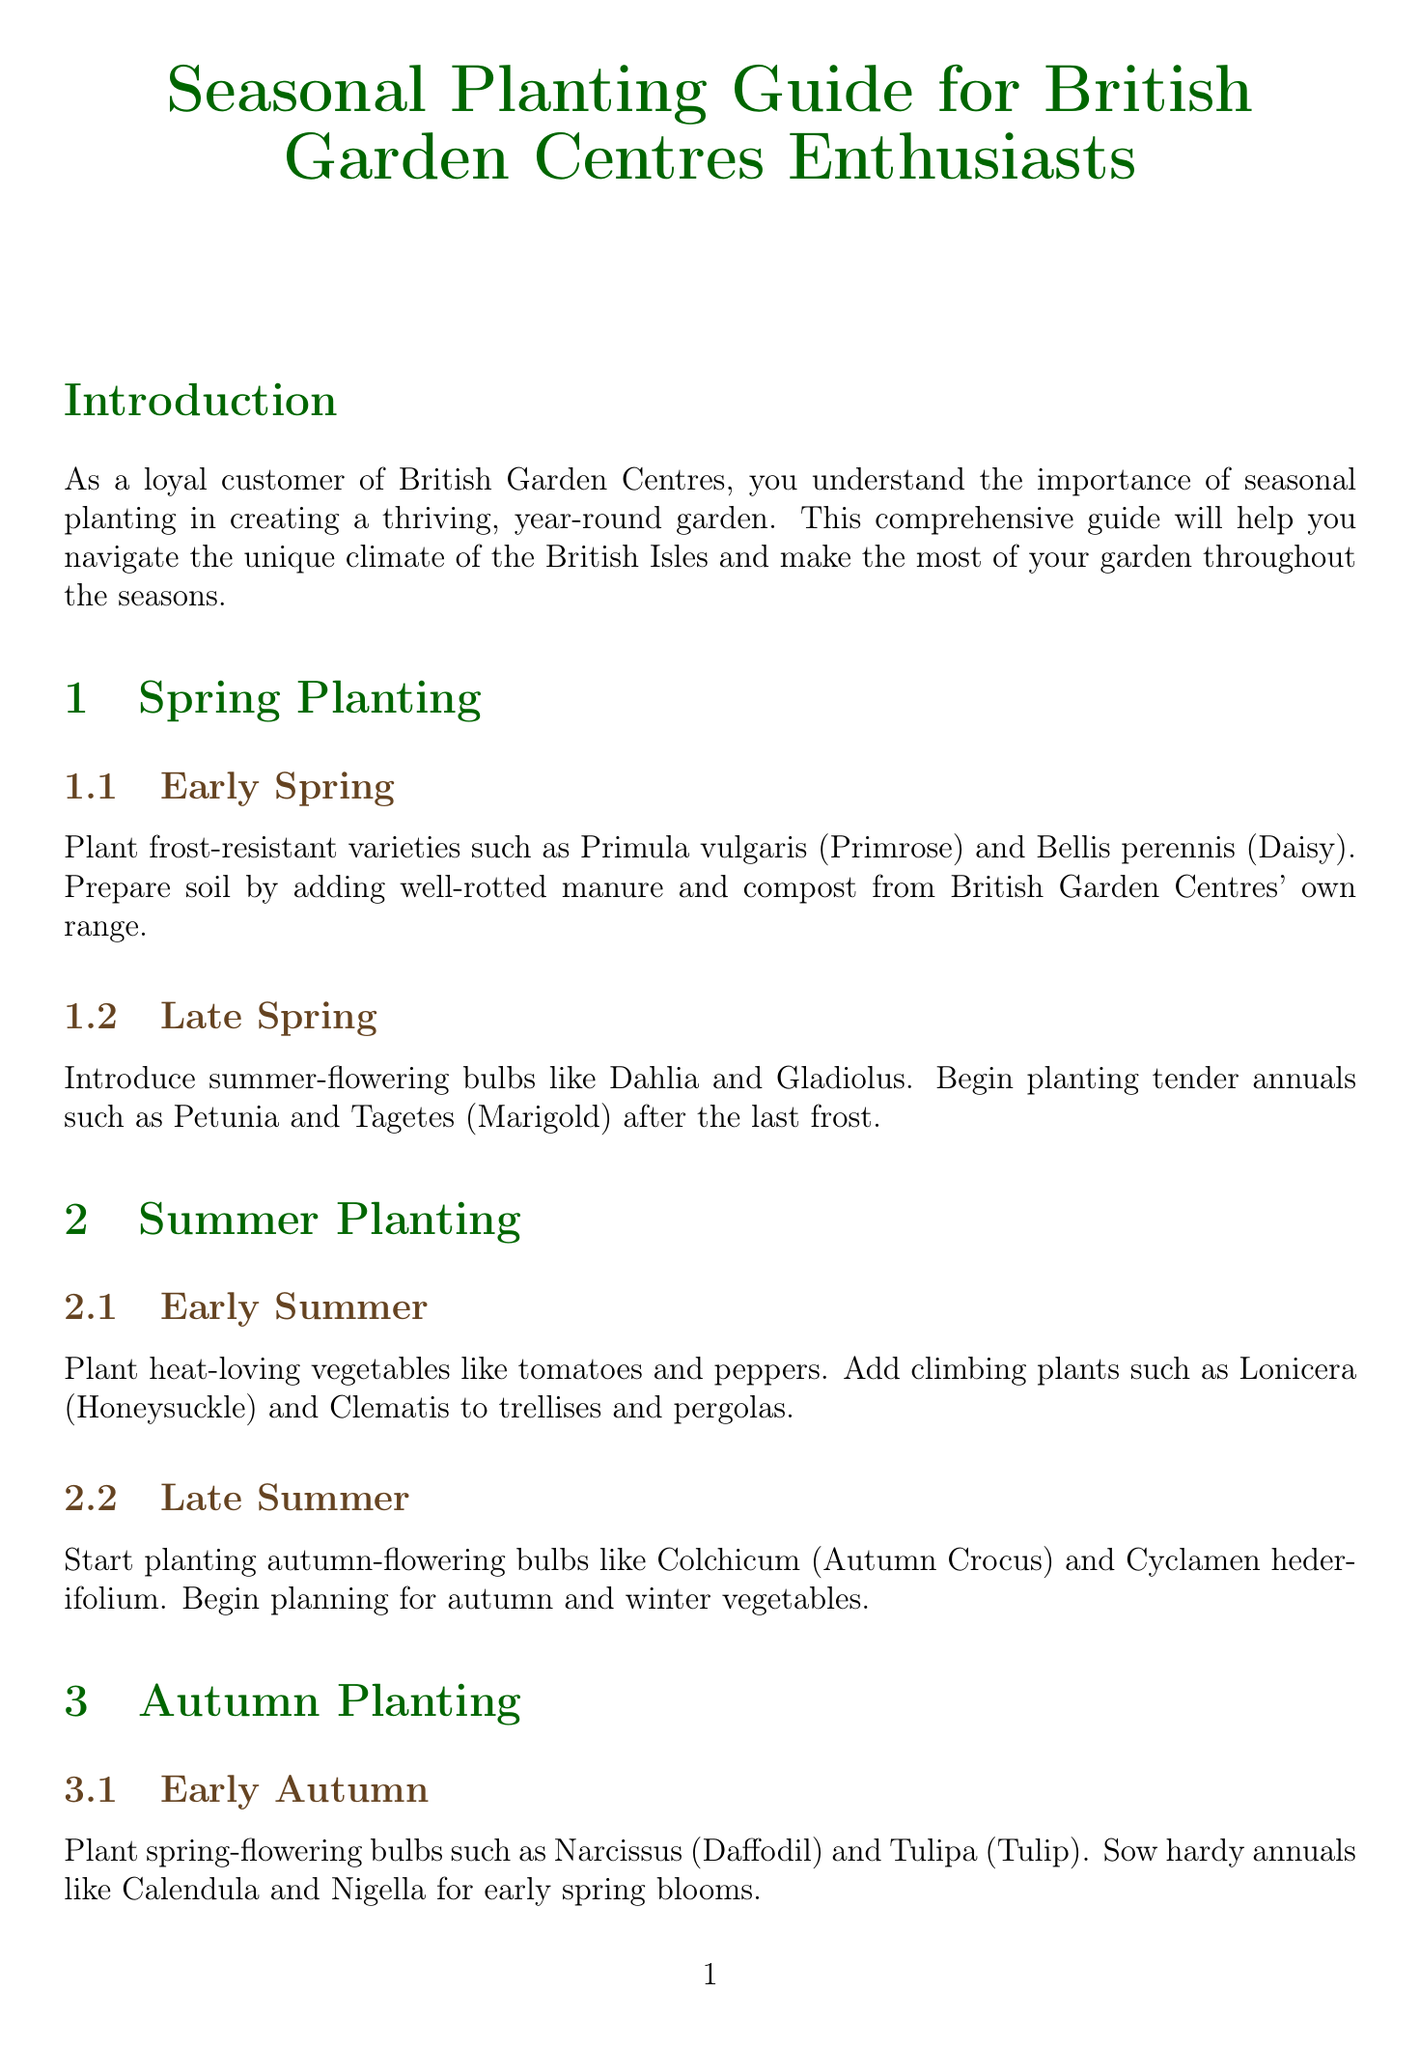What varieties should be planted in early spring? The document mentions frost-resistant varieties such as Primula vulgaris (Primrose) and Bellis perennis (Daisy) for early spring planting.
Answer: Primula vulgaris, Bellis perennis What is recommended for improving drainage in heavy clay soils? The document states that for heavy clay soils, grit or sharp sand should be incorporated to improve drainage.
Answer: Grit or sharp sand Which planting season is associated with planting bare-root roses? The document specifies that bare-root roses should be planted in early winter.
Answer: Early winter What type of mulch is suggested for retaining moisture? The document recommends applying a 5cm layer of organic mulch such as bark chips or well-rotted manure to retain moisture.
Answer: Organic mulch How many categories of planting seasons are mentioned in the document? The document lists four categories of planting seasons: Spring, Summer, Autumn, Winter.
Answer: Four Which climbing plants are mentioned for early summer? The document suggests adding climbing plants such as Lonicera (Honeysuckle) and Clematis for early summer planting.
Answer: Lonicera, Clematis Name a frost-resistant variety available at British Garden Centres for winter interest. The document provides examples of frost-resistant plants including Mahonia for winter interest.
Answer: Mahonia Which gardening tools are recommended for purchase? The document advises investing in quality gardening tools, including a sturdy spade, fork, rake, and hand trowel.
Answer: Sturdy spade, fork, rake, hand trowel 